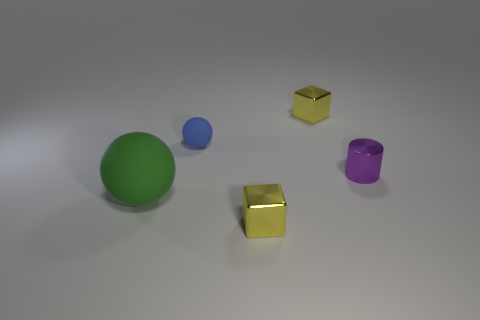Is there anything else that is the same size as the green ball? Based on my assessment, it appears that all objects in the image are of different sizes. The green ball does not have an identical-sized counterpart among the visible objects. 